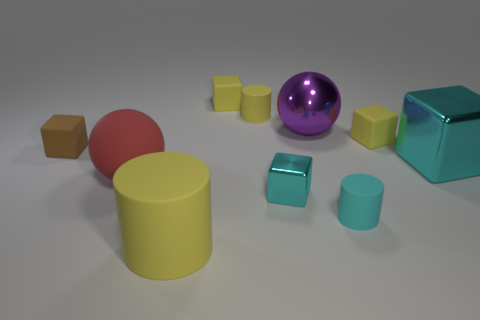How big is the cylinder on the right side of the tiny yellow cylinder?
Offer a very short reply. Small. Do the purple metallic thing and the brown rubber thing have the same size?
Offer a terse response. No. Are there fewer red rubber spheres on the left side of the big red thing than big purple metal things that are on the left side of the tiny yellow rubber cylinder?
Provide a succinct answer. No. There is a block that is both to the right of the metallic ball and on the left side of the big cyan thing; what size is it?
Make the answer very short. Small. There is a metal cube that is on the left side of the cyan matte cylinder to the right of the brown rubber block; is there a small shiny object that is in front of it?
Your answer should be very brief. No. Is there a red shiny block?
Offer a very short reply. No. Is the number of cyan metal objects that are behind the shiny sphere greater than the number of large metal objects on the left side of the large red matte sphere?
Ensure brevity in your answer.  No. The cyan cylinder that is made of the same material as the brown object is what size?
Ensure brevity in your answer.  Small. There is a yellow matte cube that is in front of the tiny yellow cylinder left of the large ball behind the small brown matte object; what is its size?
Your answer should be compact. Small. There is a tiny cube that is on the left side of the big red thing; what is its color?
Offer a terse response. Brown. 